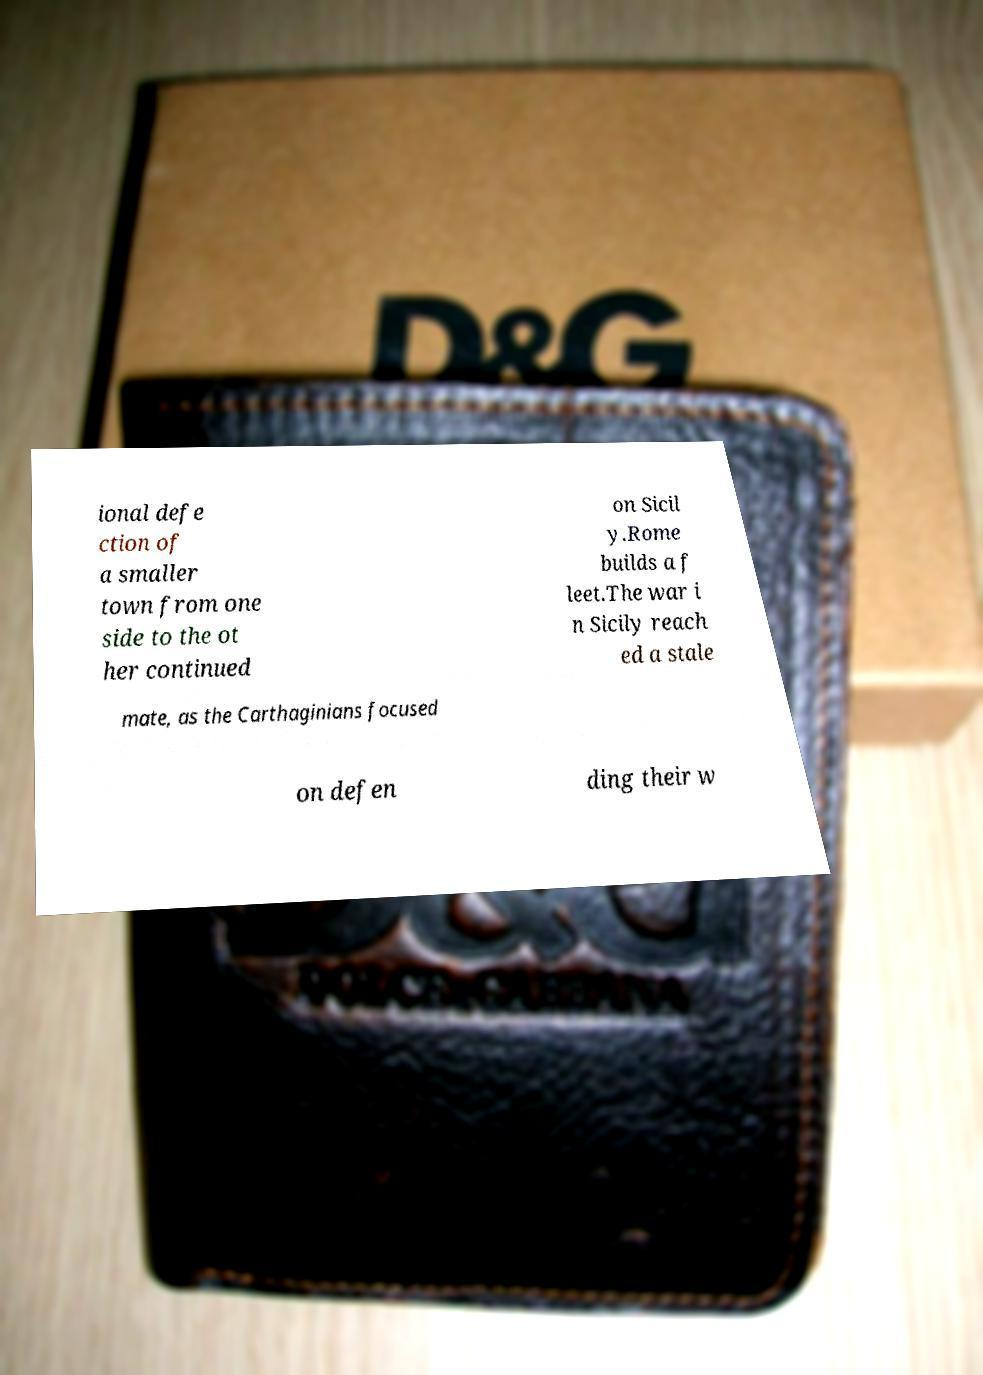Could you assist in decoding the text presented in this image and type it out clearly? ional defe ction of a smaller town from one side to the ot her continued on Sicil y.Rome builds a f leet.The war i n Sicily reach ed a stale mate, as the Carthaginians focused on defen ding their w 